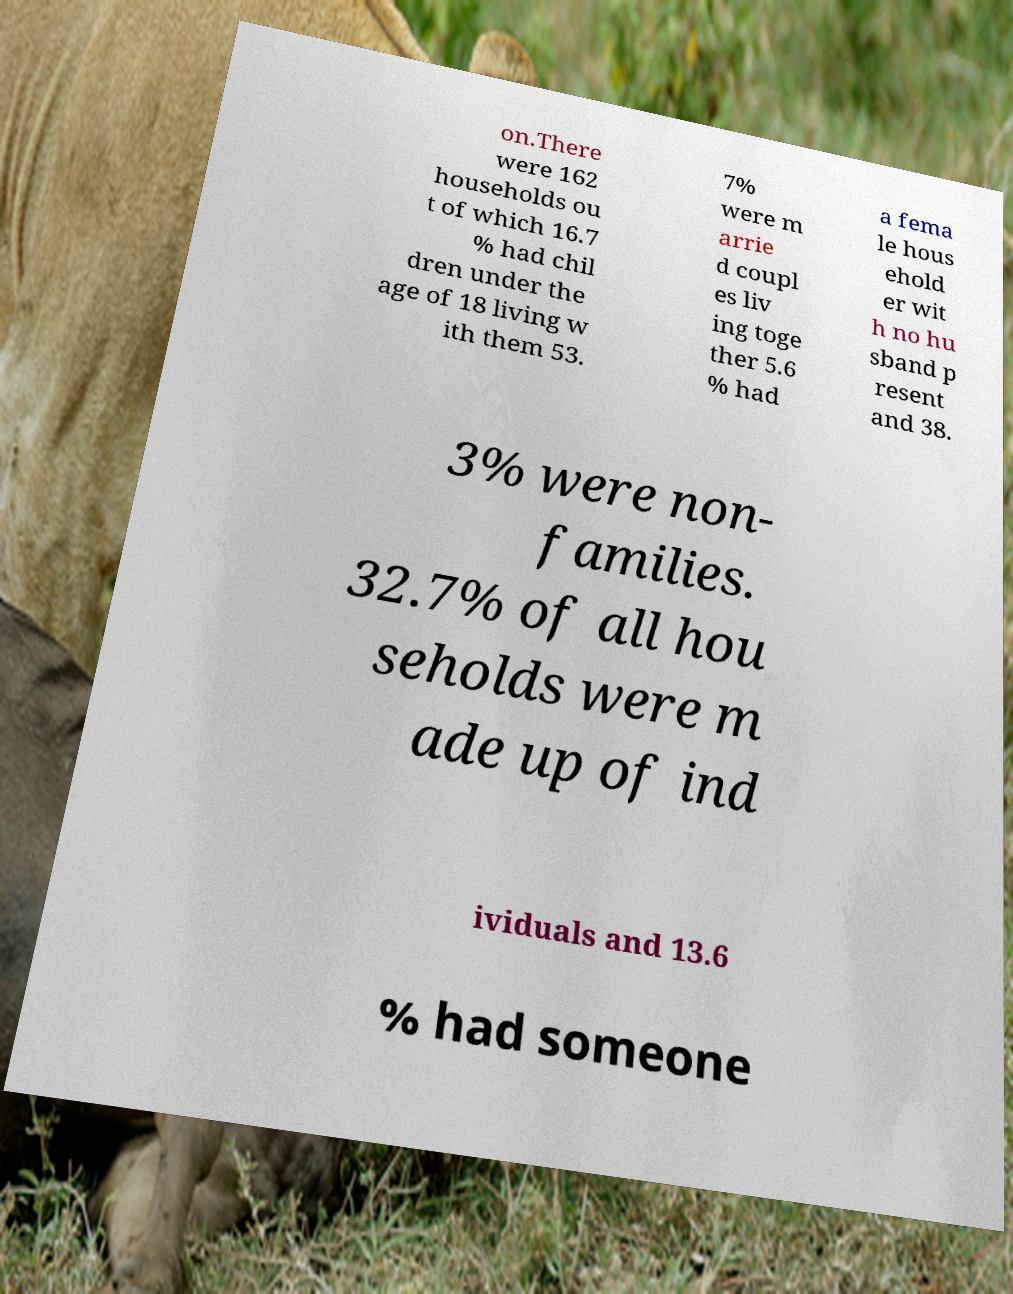For documentation purposes, I need the text within this image transcribed. Could you provide that? on.There were 162 households ou t of which 16.7 % had chil dren under the age of 18 living w ith them 53. 7% were m arrie d coupl es liv ing toge ther 5.6 % had a fema le hous ehold er wit h no hu sband p resent and 38. 3% were non- families. 32.7% of all hou seholds were m ade up of ind ividuals and 13.6 % had someone 